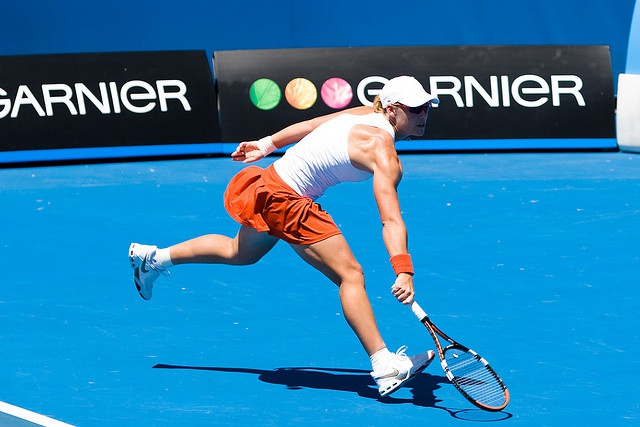Describe the objects in this image and their specific colors. I can see people in darkblue, white, tan, and salmon tones and tennis racket in darkblue, gray, lightblue, black, and white tones in this image. 